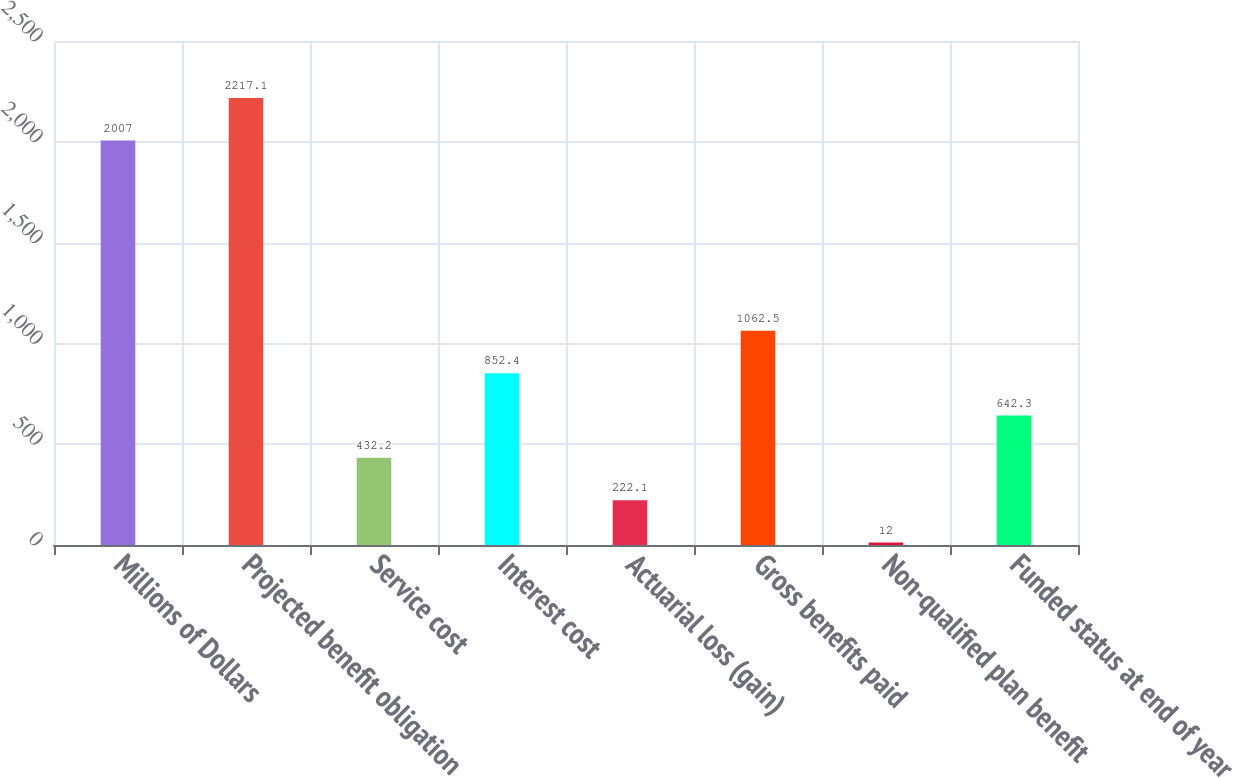Convert chart to OTSL. <chart><loc_0><loc_0><loc_500><loc_500><bar_chart><fcel>Millions of Dollars<fcel>Projected benefit obligation<fcel>Service cost<fcel>Interest cost<fcel>Actuarial loss (gain)<fcel>Gross benefits paid<fcel>Non-qualified plan benefit<fcel>Funded status at end of year<nl><fcel>2007<fcel>2217.1<fcel>432.2<fcel>852.4<fcel>222.1<fcel>1062.5<fcel>12<fcel>642.3<nl></chart> 